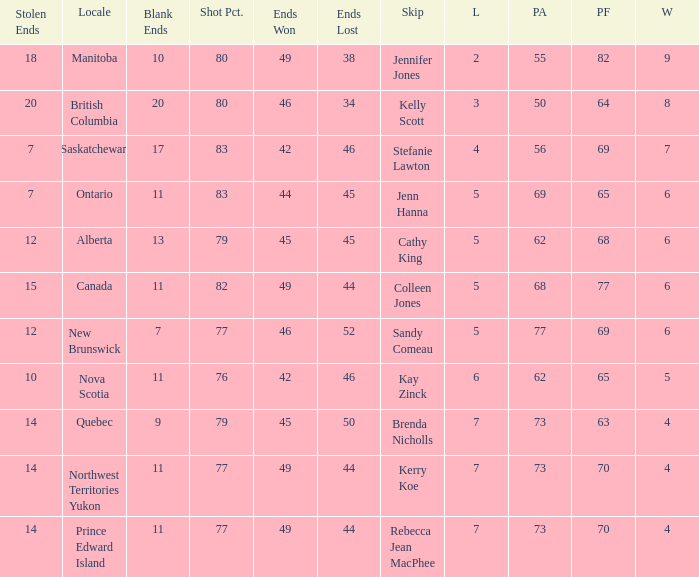What is the PA when the PF is 77? 68.0. 